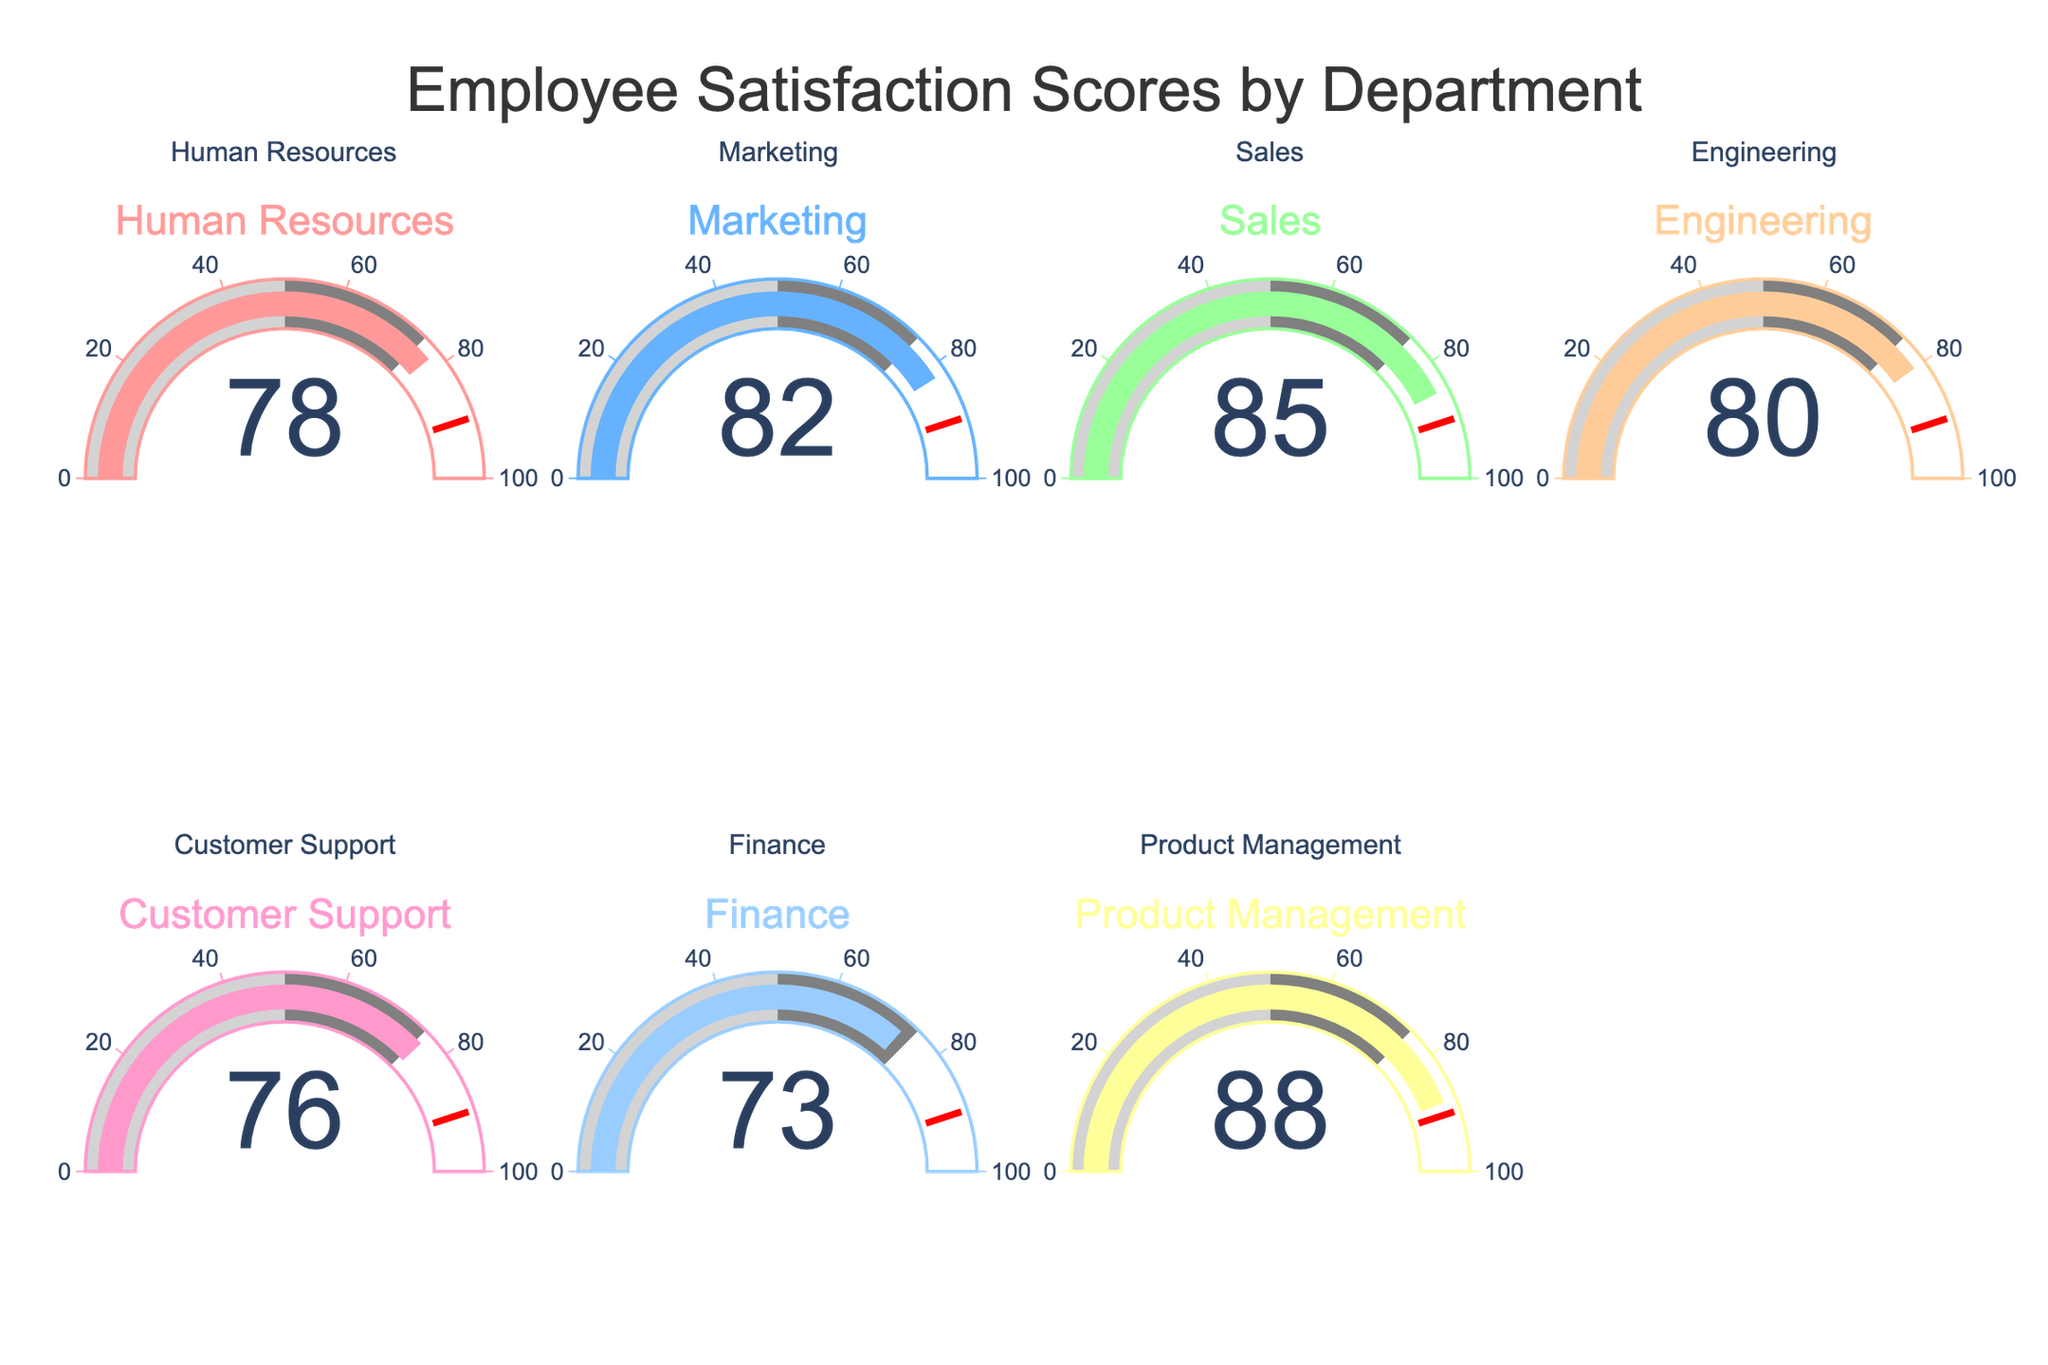What's the title of the figure? The title of the figure is positioned at the top center and can be clearly read as "Employee Satisfaction Scores by Department".
Answer: Employee Satisfaction Scores by Department Which department has the highest satisfaction score? By examining the gauges, the department with the highest score is indicated by the gauge showing the value 88. This corresponds to Product Management.
Answer: Product Management How many departments have a satisfaction score below 80? By counting the gauged departments with values below 80: Human Resources (78), Customer Support (76), and Finance (73). Thus, there are three departments with scores below 80.
Answer: 3 Compare the satisfaction scores of Sales and Engineering. Which one is higher and by how much? The satisfaction score of Sales is 85 and for Engineering, it is 80. By subtracting the latter from the former (85 - 80), Sales has a higher satisfaction score by 5 points.
Answer: Sales, by 5 What's the total sum of satisfaction scores for all departments? Summing the values 78, 82, 85, 80, 76, 73, and 88 results in a total satisfaction score. The calculation is 78 + 82 + 85 + 80 + 76 + 73 + 88 = 562.
Answer: 562 Which departments fall within the satisfaction score range of 70 to 79, inclusive? The departments within this range have scores: Human Resources (78), Customer Support (76), and Finance (73).
Answer: Human Resources, Customer Support, Finance What's the average satisfaction score of all departments excluding the highest and lowest values? Excluding the highest score (88) and the lowest score (73), the remaining scores are 78, 82, 85, 80, and 76. Summing these (78 + 82 + 85 + 80 + 76 = 401) and dividing by their count (5) gives an average score of 80.2.
Answer: 80.2 What is the difference between the highest and lowest satisfaction scores? The highest satisfaction score is 88 (Product Management) and the lowest is 73 (Finance). The difference is calculated as 88 - 73 = 15.
Answer: 15 How many departments have satisfaction scores above 75? By counting the gauges with values above 75: Human Resources (78), Marketing (82), Sales (85), Engineering (80), Customer Support (76), and Product Management (88). Thus, there are six departments with scores above 75.
Answer: 6 